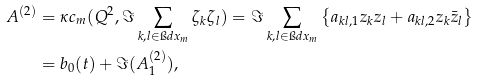<formula> <loc_0><loc_0><loc_500><loc_500>A ^ { ( 2 ) } & = \kappa c _ { m } ( Q ^ { 2 } , \Im \sum _ { k , l \in \i d x _ { m } } \zeta _ { k } \zeta _ { l } ) = \Im \sum _ { k , l \in \i d x _ { m } } \left \{ a _ { k l , 1 } z _ { k } z _ { l } + a _ { k l , 2 } z _ { k } \bar { z } _ { l } \right \} \\ & = b _ { 0 } ( t ) + \Im ( A _ { 1 } ^ { ( 2 ) } ) ,</formula> 